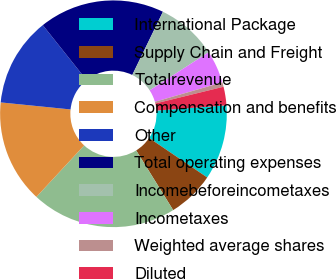<chart> <loc_0><loc_0><loc_500><loc_500><pie_chart><fcel>International Package<fcel>Supply Chain and Freight<fcel>Totalrevenue<fcel>Compensation and benefits<fcel>Other<fcel>Total operating expenses<fcel>Incomebeforeincometaxes<fcel>Incometaxes<fcel>Weighted average shares<fcel>Diluted<nl><fcel>10.68%<fcel>6.67%<fcel>20.73%<fcel>14.7%<fcel>12.69%<fcel>17.9%<fcel>8.68%<fcel>4.66%<fcel>0.64%<fcel>2.65%<nl></chart> 